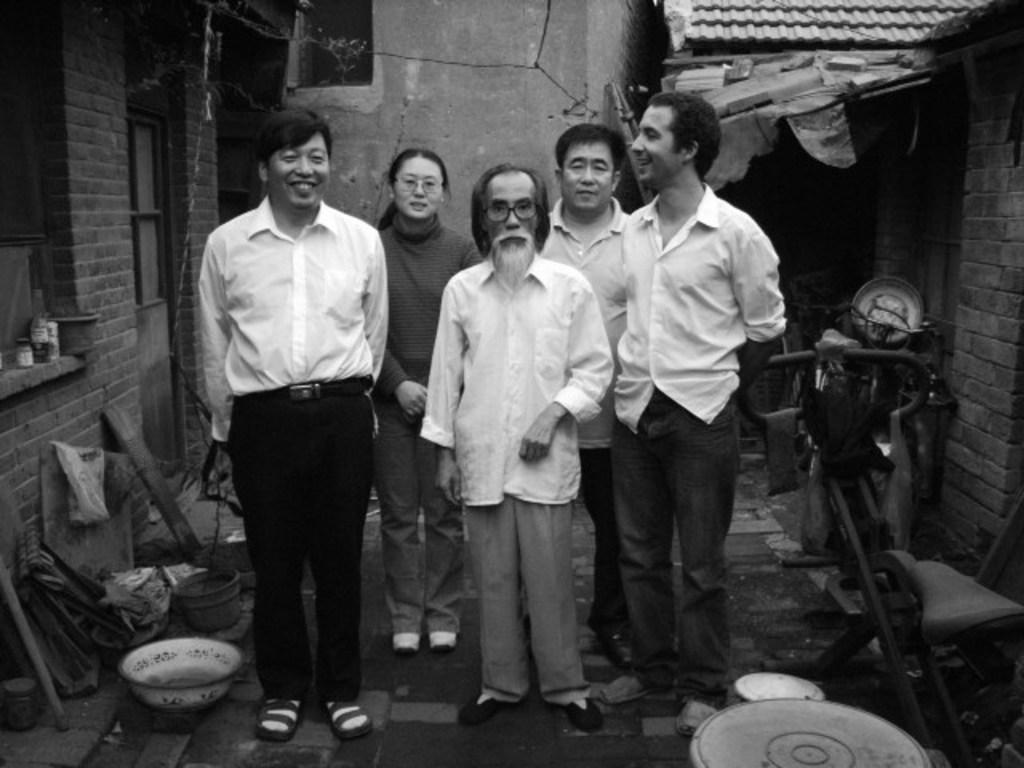How many people are in the image? There are four men and one woman in the image, making a total of five people. What is the setting of the image? The people are standing on land, with homes on either side of them. What objects can be seen in the image? There are utensils and scrap visible in the image. What type of memory is being used by the cow in the image? There is no cow present in the image, so it is not possible to determine what type of memory might be used by a cow. 